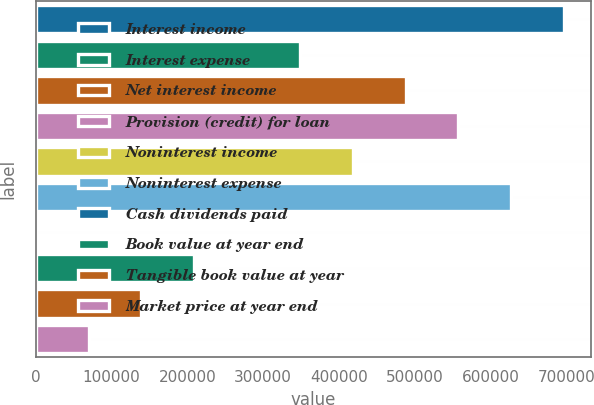<chart> <loc_0><loc_0><loc_500><loc_500><bar_chart><fcel>Interest income<fcel>Interest expense<fcel>Net interest income<fcel>Provision (credit) for loan<fcel>Noninterest income<fcel>Noninterest expense<fcel>Cash dividends paid<fcel>Book value at year end<fcel>Tangible book value at year<fcel>Market price at year end<nl><fcel>697155<fcel>348578<fcel>488009<fcel>557724<fcel>418293<fcel>627440<fcel>0.09<fcel>209147<fcel>139431<fcel>69715.6<nl></chart> 